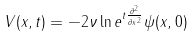<formula> <loc_0><loc_0><loc_500><loc_500>V ( x , t ) = - 2 \nu \ln e ^ { t \frac { \partial ^ { 2 } } { \partial x ^ { 2 } } } \psi ( x , 0 )</formula> 